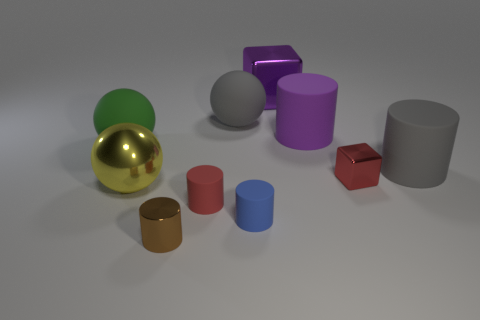There is a big metal object that is in front of the big matte ball in front of the big purple cylinder; what number of tiny red matte cylinders are on the left side of it?
Your answer should be compact. 0. Is there anything else that has the same color as the small metallic cylinder?
Offer a very short reply. No. There is a tiny shiny object that is on the right side of the purple metallic thing; is it the same color as the tiny rubber cylinder left of the large gray ball?
Ensure brevity in your answer.  Yes. Are there more big matte cylinders on the right side of the tiny metal block than small metallic objects right of the brown object?
Give a very brief answer. No. What is the material of the blue cylinder?
Keep it short and to the point. Rubber. The large rubber object that is on the left side of the large metal thing to the left of the metallic thing in front of the red rubber object is what shape?
Provide a short and direct response. Sphere. What number of other objects are there of the same material as the big purple cylinder?
Keep it short and to the point. 5. Do the red object that is to the left of the blue rubber cylinder and the ball that is in front of the green matte ball have the same material?
Keep it short and to the point. No. How many cylinders are both behind the shiny sphere and in front of the large yellow ball?
Your answer should be compact. 0. Is there a big brown shiny thing of the same shape as the yellow thing?
Your answer should be very brief. No. 